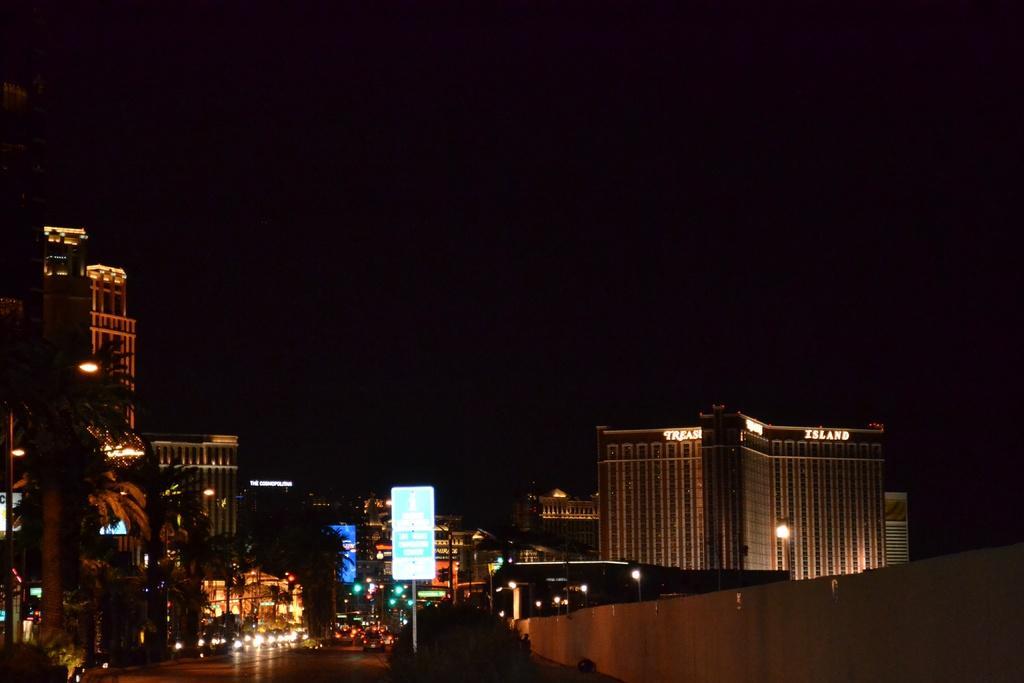In one or two sentences, can you explain what this image depicts? At the bottom of the image there are some trees and sign boards and buildings and vehicles. 